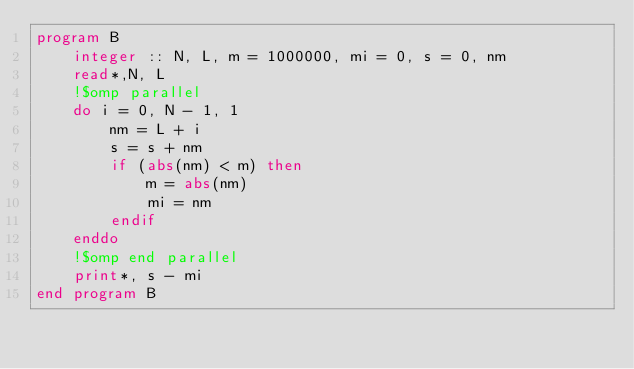<code> <loc_0><loc_0><loc_500><loc_500><_FORTRAN_>program B
    integer :: N, L, m = 1000000, mi = 0, s = 0, nm
    read*,N, L
    !$omp parallel
    do i = 0, N - 1, 1
        nm = L + i
        s = s + nm
        if (abs(nm) < m) then
            m = abs(nm)
            mi = nm
        endif
    enddo
    !$omp end parallel
    print*, s - mi
end program B</code> 